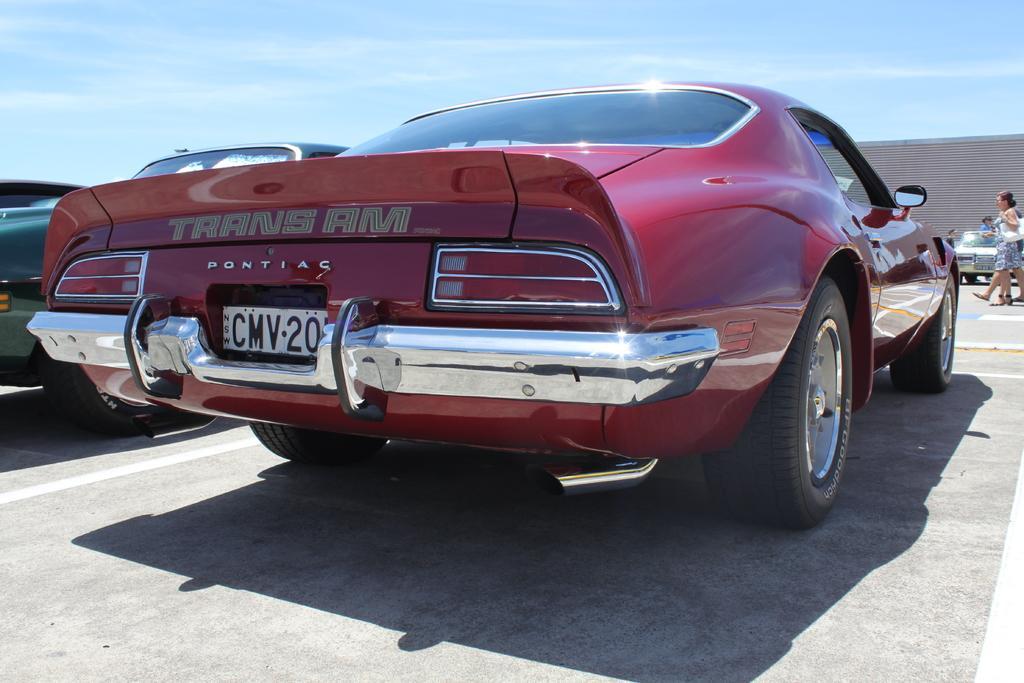Can you describe this image briefly? In this image I can see few cars and few people are walking. The sky is in blue and white color. 